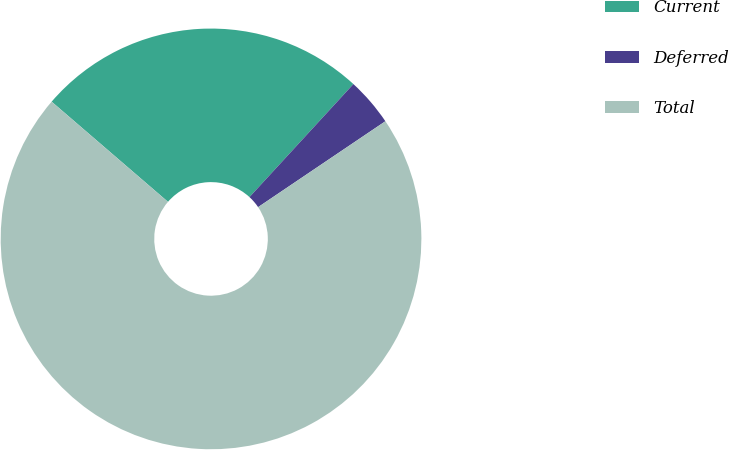Convert chart. <chart><loc_0><loc_0><loc_500><loc_500><pie_chart><fcel>Current<fcel>Deferred<fcel>Total<nl><fcel>25.52%<fcel>3.72%<fcel>70.76%<nl></chart> 